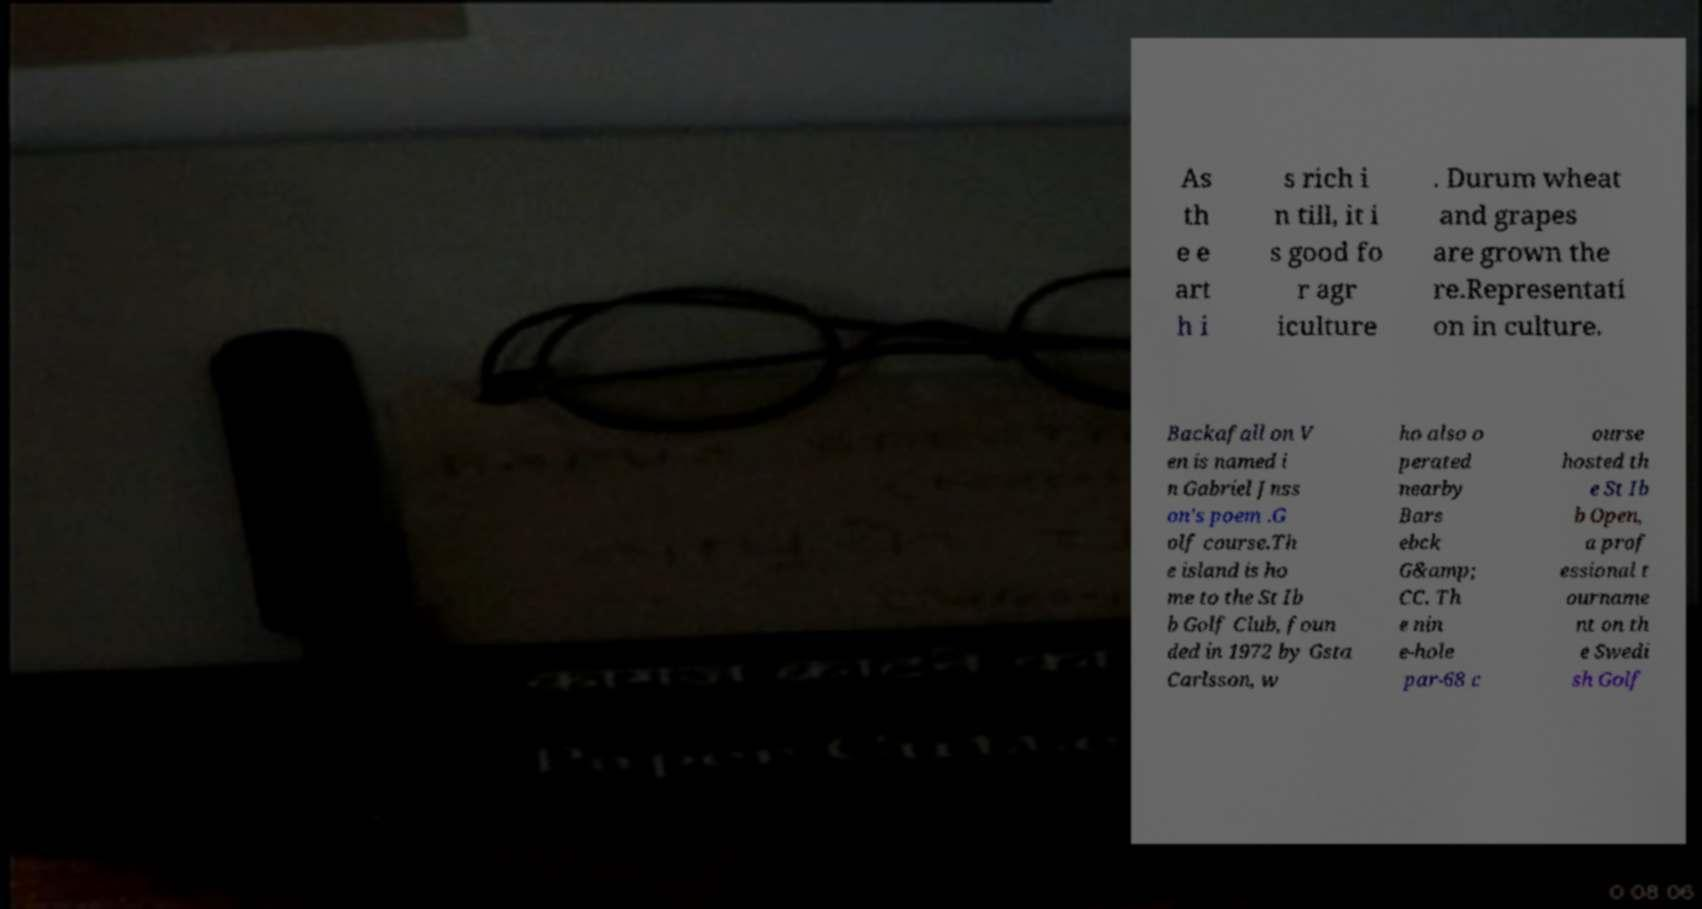I need the written content from this picture converted into text. Can you do that? As th e e art h i s rich i n till, it i s good fo r agr iculture . Durum wheat and grapes are grown the re.Representati on in culture. Backafall on V en is named i n Gabriel Jnss on's poem .G olf course.Th e island is ho me to the St Ib b Golf Club, foun ded in 1972 by Gsta Carlsson, w ho also o perated nearby Bars ebck G&amp; CC. Th e nin e-hole par-68 c ourse hosted th e St Ib b Open, a prof essional t ourname nt on th e Swedi sh Golf 